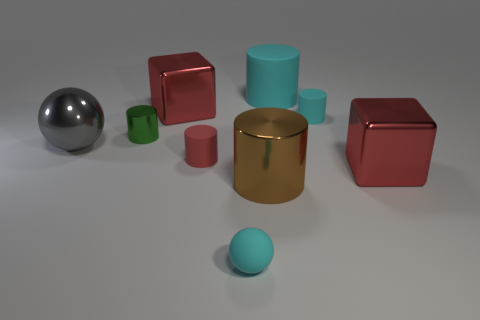How many other things are the same shape as the tiny red matte object?
Offer a terse response. 4. There is a sphere that is to the left of the cyan rubber object that is on the left side of the brown object; what is its material?
Make the answer very short. Metal. Is there anything else that is the same size as the green shiny cylinder?
Your answer should be compact. Yes. Are the small cyan cylinder and the large block on the right side of the big rubber object made of the same material?
Make the answer very short. No. There is a large object that is right of the large gray metallic thing and to the left of the brown metallic thing; what material is it made of?
Provide a succinct answer. Metal. There is a cylinder in front of the red block to the right of the red matte cylinder; what color is it?
Give a very brief answer. Brown. There is a tiny cyan ball that is to the right of the red matte object; what material is it?
Provide a short and direct response. Rubber. Is the number of large brown cylinders less than the number of small cyan rubber things?
Provide a succinct answer. Yes. There is a green metal thing; does it have the same shape as the small cyan matte thing that is to the left of the large brown cylinder?
Provide a succinct answer. No. There is a tiny thing that is right of the red cylinder and in front of the tiny shiny thing; what shape is it?
Provide a succinct answer. Sphere. 